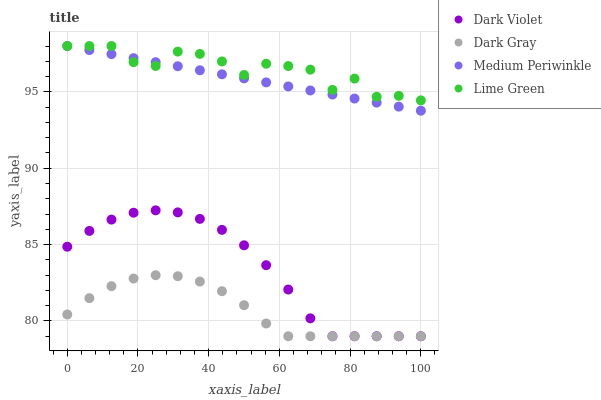Does Dark Gray have the minimum area under the curve?
Answer yes or no. Yes. Does Lime Green have the maximum area under the curve?
Answer yes or no. Yes. Does Medium Periwinkle have the minimum area under the curve?
Answer yes or no. No. Does Medium Periwinkle have the maximum area under the curve?
Answer yes or no. No. Is Medium Periwinkle the smoothest?
Answer yes or no. Yes. Is Lime Green the roughest?
Answer yes or no. Yes. Is Lime Green the smoothest?
Answer yes or no. No. Is Medium Periwinkle the roughest?
Answer yes or no. No. Does Dark Gray have the lowest value?
Answer yes or no. Yes. Does Medium Periwinkle have the lowest value?
Answer yes or no. No. Does Medium Periwinkle have the highest value?
Answer yes or no. Yes. Does Dark Violet have the highest value?
Answer yes or no. No. Is Dark Violet less than Medium Periwinkle?
Answer yes or no. Yes. Is Lime Green greater than Dark Violet?
Answer yes or no. Yes. Does Dark Gray intersect Dark Violet?
Answer yes or no. Yes. Is Dark Gray less than Dark Violet?
Answer yes or no. No. Is Dark Gray greater than Dark Violet?
Answer yes or no. No. Does Dark Violet intersect Medium Periwinkle?
Answer yes or no. No. 